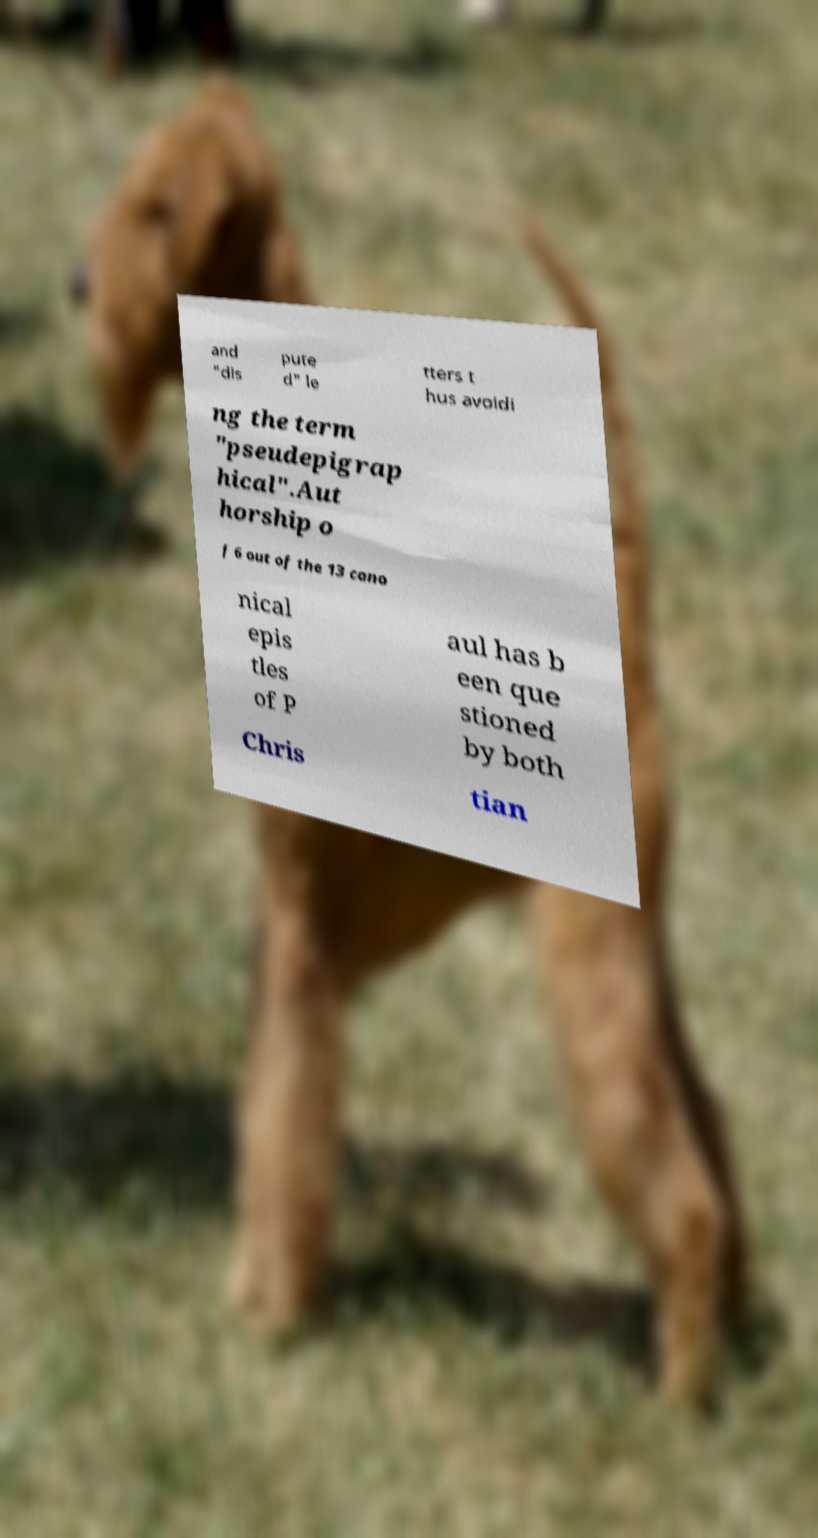Can you read and provide the text displayed in the image?This photo seems to have some interesting text. Can you extract and type it out for me? and "dis pute d" le tters t hus avoidi ng the term "pseudepigrap hical".Aut horship o f 6 out of the 13 cano nical epis tles of P aul has b een que stioned by both Chris tian 